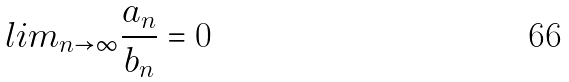Convert formula to latex. <formula><loc_0><loc_0><loc_500><loc_500>l i m _ { n \rightarrow \infty } \frac { a _ { n } } { b _ { n } } = 0</formula> 